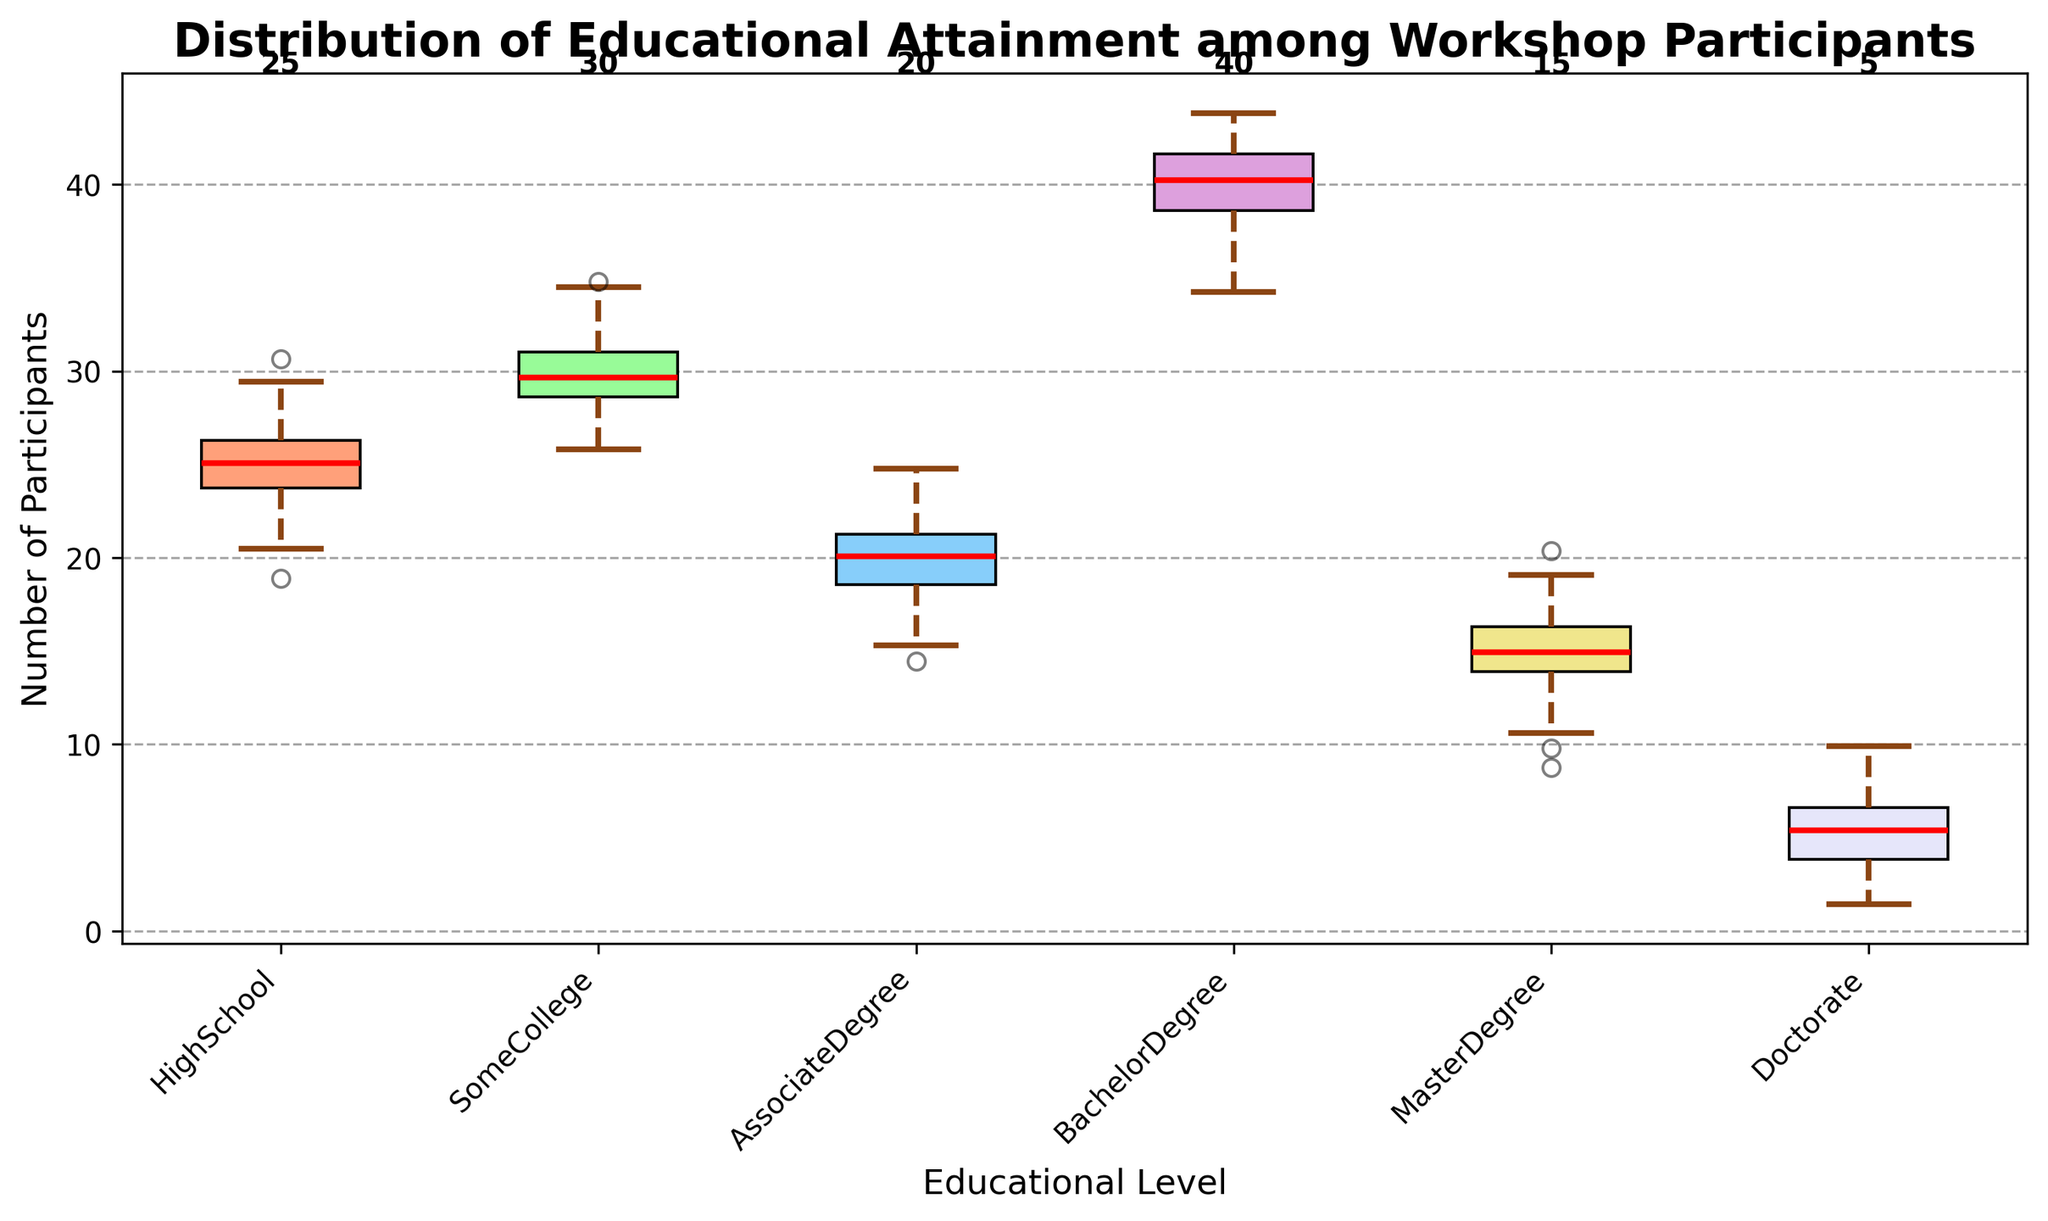What is the median number of participants with a Bachelor's Degree? The median in a box plot is indicated by the red line inside the box for the Bachelor's Degree category.
Answer: Approximately 40 What is the title of the box plot? The title of the box plot is displayed at the top and reads "Distribution of Educational Attainment among Workshop Participants".
Answer: Distribution of Educational Attainment among Workshop Participants How many educational levels are represented in the box plot? Count the number of distinct boxes or labels on the x-axis. There are six educational levels: High School, Some College, Associate Degree, Bachelor Degree, Master Degree, and Doctorate.
Answer: 6 Which educational level has the smallest range of participants? The range in a box plot is the difference between the highest and lowest whiskers. The Doctorate category has the smallest range due to the tight clustering of the whiskers.
Answer: Doctorate What color is the box for the Master's Degree category? Identify the color used for the box representing the Master's Degree category, which is light yellow or khaki.
Answer: Khaki Which educational level has the largest number of participants, based on the numbers shown above the boxes? Look at the numbers displayed above each box. The Bachelor's Degree category has the number 40 above it, which is the highest.
Answer: Bachelor Degree Compare the medians of the High School and Some College categories. Which has a higher median number of participants? Look at the red lines inside the boxes for both High School and Some College categories. The median line for Some College is higher than that of High School.
Answer: Some College Are there any outliers in the Master's Degree category? Outliers in a box plot are shown as individual points outside the whiskers. None are present in the Master's Degree category.
Answer: No What is the label of the y-axis? The label of the y-axis can be found beside the vertical axis and reads "Number of Participants".
Answer: Number of Participants 